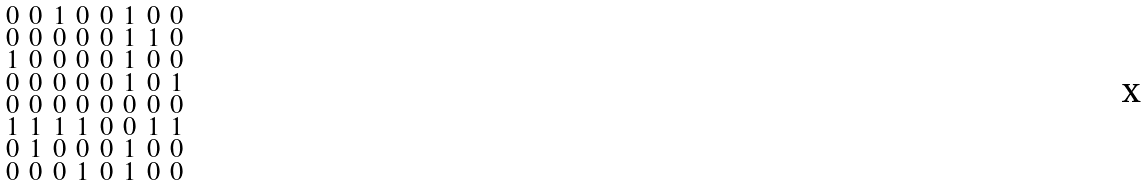Convert formula to latex. <formula><loc_0><loc_0><loc_500><loc_500>\begin{smallmatrix} 0 & 0 & 1 & 0 & 0 & 1 & 0 & 0 \\ 0 & 0 & 0 & 0 & 0 & 1 & 1 & 0 \\ 1 & 0 & 0 & 0 & 0 & 1 & 0 & 0 \\ 0 & 0 & 0 & 0 & 0 & 1 & 0 & 1 \\ 0 & 0 & 0 & 0 & 0 & 0 & 0 & 0 \\ 1 & 1 & 1 & 1 & 0 & 0 & 1 & 1 \\ 0 & 1 & 0 & 0 & 0 & 1 & 0 & 0 \\ 0 & 0 & 0 & 1 & 0 & 1 & 0 & 0 \end{smallmatrix}</formula> 